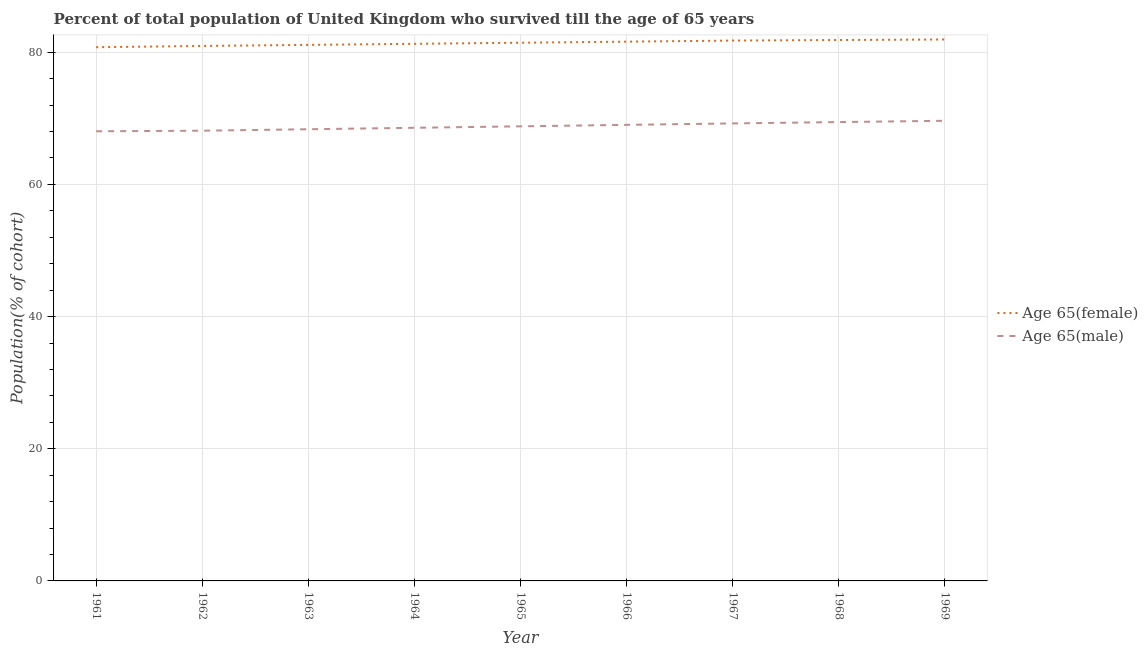How many different coloured lines are there?
Make the answer very short. 2. Does the line corresponding to percentage of male population who survived till age of 65 intersect with the line corresponding to percentage of female population who survived till age of 65?
Your answer should be compact. No. What is the percentage of male population who survived till age of 65 in 1964?
Your response must be concise. 68.57. Across all years, what is the maximum percentage of male population who survived till age of 65?
Provide a succinct answer. 69.63. Across all years, what is the minimum percentage of female population who survived till age of 65?
Offer a terse response. 80.76. In which year was the percentage of male population who survived till age of 65 maximum?
Offer a very short reply. 1969. What is the total percentage of female population who survived till age of 65 in the graph?
Ensure brevity in your answer.  732.68. What is the difference between the percentage of male population who survived till age of 65 in 1965 and that in 1967?
Your answer should be compact. -0.44. What is the difference between the percentage of male population who survived till age of 65 in 1961 and the percentage of female population who survived till age of 65 in 1967?
Make the answer very short. -13.73. What is the average percentage of female population who survived till age of 65 per year?
Give a very brief answer. 81.41. In the year 1965, what is the difference between the percentage of male population who survived till age of 65 and percentage of female population who survived till age of 65?
Provide a succinct answer. -12.65. What is the ratio of the percentage of male population who survived till age of 65 in 1967 to that in 1969?
Make the answer very short. 0.99. Is the percentage of female population who survived till age of 65 in 1966 less than that in 1967?
Give a very brief answer. Yes. What is the difference between the highest and the second highest percentage of male population who survived till age of 65?
Your answer should be very brief. 0.2. What is the difference between the highest and the lowest percentage of male population who survived till age of 65?
Provide a short and direct response. 1.59. In how many years, is the percentage of female population who survived till age of 65 greater than the average percentage of female population who survived till age of 65 taken over all years?
Give a very brief answer. 5. Is the sum of the percentage of male population who survived till age of 65 in 1961 and 1967 greater than the maximum percentage of female population who survived till age of 65 across all years?
Provide a short and direct response. Yes. Does the percentage of female population who survived till age of 65 monotonically increase over the years?
Offer a terse response. Yes. Is the percentage of male population who survived till age of 65 strictly greater than the percentage of female population who survived till age of 65 over the years?
Keep it short and to the point. No. Is the percentage of male population who survived till age of 65 strictly less than the percentage of female population who survived till age of 65 over the years?
Offer a terse response. Yes. What is the difference between two consecutive major ticks on the Y-axis?
Give a very brief answer. 20. Where does the legend appear in the graph?
Provide a succinct answer. Center right. How are the legend labels stacked?
Provide a short and direct response. Vertical. What is the title of the graph?
Provide a short and direct response. Percent of total population of United Kingdom who survived till the age of 65 years. Does "Urban agglomerations" appear as one of the legend labels in the graph?
Your answer should be compact. No. What is the label or title of the Y-axis?
Make the answer very short. Population(% of cohort). What is the Population(% of cohort) of Age 65(female) in 1961?
Provide a succinct answer. 80.76. What is the Population(% of cohort) of Age 65(male) in 1961?
Your answer should be very brief. 68.04. What is the Population(% of cohort) in Age 65(female) in 1962?
Offer a very short reply. 80.95. What is the Population(% of cohort) in Age 65(male) in 1962?
Your response must be concise. 68.13. What is the Population(% of cohort) in Age 65(female) in 1963?
Your response must be concise. 81.11. What is the Population(% of cohort) of Age 65(male) in 1963?
Make the answer very short. 68.35. What is the Population(% of cohort) of Age 65(female) in 1964?
Your response must be concise. 81.28. What is the Population(% of cohort) in Age 65(male) in 1964?
Keep it short and to the point. 68.57. What is the Population(% of cohort) of Age 65(female) in 1965?
Ensure brevity in your answer.  81.44. What is the Population(% of cohort) of Age 65(male) in 1965?
Your answer should be compact. 68.79. What is the Population(% of cohort) in Age 65(female) in 1966?
Provide a short and direct response. 81.6. What is the Population(% of cohort) of Age 65(male) in 1966?
Your response must be concise. 69.01. What is the Population(% of cohort) in Age 65(female) in 1967?
Give a very brief answer. 81.76. What is the Population(% of cohort) in Age 65(male) in 1967?
Make the answer very short. 69.23. What is the Population(% of cohort) of Age 65(female) in 1968?
Your response must be concise. 81.85. What is the Population(% of cohort) of Age 65(male) in 1968?
Offer a very short reply. 69.43. What is the Population(% of cohort) in Age 65(female) in 1969?
Provide a short and direct response. 81.93. What is the Population(% of cohort) in Age 65(male) in 1969?
Give a very brief answer. 69.63. Across all years, what is the maximum Population(% of cohort) in Age 65(female)?
Offer a terse response. 81.93. Across all years, what is the maximum Population(% of cohort) of Age 65(male)?
Ensure brevity in your answer.  69.63. Across all years, what is the minimum Population(% of cohort) of Age 65(female)?
Give a very brief answer. 80.76. Across all years, what is the minimum Population(% of cohort) in Age 65(male)?
Your answer should be very brief. 68.04. What is the total Population(% of cohort) in Age 65(female) in the graph?
Your answer should be very brief. 732.68. What is the total Population(% of cohort) in Age 65(male) in the graph?
Your answer should be compact. 619.17. What is the difference between the Population(% of cohort) in Age 65(female) in 1961 and that in 1962?
Your response must be concise. -0.19. What is the difference between the Population(% of cohort) of Age 65(male) in 1961 and that in 1962?
Offer a very short reply. -0.09. What is the difference between the Population(% of cohort) of Age 65(female) in 1961 and that in 1963?
Your response must be concise. -0.35. What is the difference between the Population(% of cohort) of Age 65(male) in 1961 and that in 1963?
Provide a short and direct response. -0.31. What is the difference between the Population(% of cohort) of Age 65(female) in 1961 and that in 1964?
Offer a terse response. -0.51. What is the difference between the Population(% of cohort) of Age 65(male) in 1961 and that in 1964?
Provide a succinct answer. -0.53. What is the difference between the Population(% of cohort) of Age 65(female) in 1961 and that in 1965?
Offer a very short reply. -0.68. What is the difference between the Population(% of cohort) in Age 65(male) in 1961 and that in 1965?
Provide a short and direct response. -0.75. What is the difference between the Population(% of cohort) of Age 65(female) in 1961 and that in 1966?
Provide a succinct answer. -0.84. What is the difference between the Population(% of cohort) of Age 65(male) in 1961 and that in 1966?
Your answer should be compact. -0.97. What is the difference between the Population(% of cohort) in Age 65(female) in 1961 and that in 1967?
Your answer should be compact. -1. What is the difference between the Population(% of cohort) in Age 65(male) in 1961 and that in 1967?
Offer a very short reply. -1.19. What is the difference between the Population(% of cohort) in Age 65(female) in 1961 and that in 1968?
Your response must be concise. -1.09. What is the difference between the Population(% of cohort) of Age 65(male) in 1961 and that in 1968?
Give a very brief answer. -1.39. What is the difference between the Population(% of cohort) in Age 65(female) in 1961 and that in 1969?
Make the answer very short. -1.17. What is the difference between the Population(% of cohort) of Age 65(male) in 1961 and that in 1969?
Your answer should be very brief. -1.59. What is the difference between the Population(% of cohort) in Age 65(female) in 1962 and that in 1963?
Offer a terse response. -0.16. What is the difference between the Population(% of cohort) in Age 65(male) in 1962 and that in 1963?
Ensure brevity in your answer.  -0.22. What is the difference between the Population(% of cohort) of Age 65(female) in 1962 and that in 1964?
Ensure brevity in your answer.  -0.33. What is the difference between the Population(% of cohort) of Age 65(male) in 1962 and that in 1964?
Keep it short and to the point. -0.44. What is the difference between the Population(% of cohort) of Age 65(female) in 1962 and that in 1965?
Your response must be concise. -0.49. What is the difference between the Population(% of cohort) of Age 65(male) in 1962 and that in 1965?
Keep it short and to the point. -0.66. What is the difference between the Population(% of cohort) of Age 65(female) in 1962 and that in 1966?
Provide a succinct answer. -0.65. What is the difference between the Population(% of cohort) in Age 65(male) in 1962 and that in 1966?
Give a very brief answer. -0.88. What is the difference between the Population(% of cohort) in Age 65(female) in 1962 and that in 1967?
Provide a short and direct response. -0.81. What is the difference between the Population(% of cohort) in Age 65(male) in 1962 and that in 1967?
Your answer should be very brief. -1.1. What is the difference between the Population(% of cohort) in Age 65(female) in 1962 and that in 1968?
Ensure brevity in your answer.  -0.9. What is the difference between the Population(% of cohort) in Age 65(male) in 1962 and that in 1968?
Give a very brief answer. -1.3. What is the difference between the Population(% of cohort) of Age 65(female) in 1962 and that in 1969?
Make the answer very short. -0.98. What is the difference between the Population(% of cohort) in Age 65(male) in 1962 and that in 1969?
Provide a short and direct response. -1.5. What is the difference between the Population(% of cohort) in Age 65(female) in 1963 and that in 1964?
Your answer should be very brief. -0.16. What is the difference between the Population(% of cohort) of Age 65(male) in 1963 and that in 1964?
Offer a terse response. -0.22. What is the difference between the Population(% of cohort) in Age 65(female) in 1963 and that in 1965?
Offer a terse response. -0.33. What is the difference between the Population(% of cohort) of Age 65(male) in 1963 and that in 1965?
Give a very brief answer. -0.44. What is the difference between the Population(% of cohort) in Age 65(female) in 1963 and that in 1966?
Your answer should be compact. -0.49. What is the difference between the Population(% of cohort) of Age 65(male) in 1963 and that in 1966?
Your answer should be compact. -0.66. What is the difference between the Population(% of cohort) in Age 65(female) in 1963 and that in 1967?
Provide a short and direct response. -0.65. What is the difference between the Population(% of cohort) in Age 65(male) in 1963 and that in 1967?
Your response must be concise. -0.88. What is the difference between the Population(% of cohort) in Age 65(female) in 1963 and that in 1968?
Make the answer very short. -0.74. What is the difference between the Population(% of cohort) of Age 65(male) in 1963 and that in 1968?
Your answer should be compact. -1.08. What is the difference between the Population(% of cohort) of Age 65(female) in 1963 and that in 1969?
Your answer should be very brief. -0.82. What is the difference between the Population(% of cohort) in Age 65(male) in 1963 and that in 1969?
Keep it short and to the point. -1.28. What is the difference between the Population(% of cohort) in Age 65(female) in 1964 and that in 1965?
Give a very brief answer. -0.16. What is the difference between the Population(% of cohort) of Age 65(male) in 1964 and that in 1965?
Ensure brevity in your answer.  -0.22. What is the difference between the Population(% of cohort) of Age 65(female) in 1964 and that in 1966?
Ensure brevity in your answer.  -0.33. What is the difference between the Population(% of cohort) of Age 65(male) in 1964 and that in 1966?
Offer a terse response. -0.44. What is the difference between the Population(% of cohort) of Age 65(female) in 1964 and that in 1967?
Give a very brief answer. -0.49. What is the difference between the Population(% of cohort) of Age 65(male) in 1964 and that in 1967?
Make the answer very short. -0.66. What is the difference between the Population(% of cohort) in Age 65(female) in 1964 and that in 1968?
Your response must be concise. -0.57. What is the difference between the Population(% of cohort) of Age 65(male) in 1964 and that in 1968?
Your response must be concise. -0.86. What is the difference between the Population(% of cohort) in Age 65(female) in 1964 and that in 1969?
Offer a very short reply. -0.66. What is the difference between the Population(% of cohort) in Age 65(male) in 1964 and that in 1969?
Your answer should be compact. -1.06. What is the difference between the Population(% of cohort) of Age 65(female) in 1965 and that in 1966?
Give a very brief answer. -0.16. What is the difference between the Population(% of cohort) in Age 65(male) in 1965 and that in 1966?
Your response must be concise. -0.22. What is the difference between the Population(% of cohort) in Age 65(female) in 1965 and that in 1967?
Your answer should be compact. -0.33. What is the difference between the Population(% of cohort) in Age 65(male) in 1965 and that in 1967?
Offer a terse response. -0.44. What is the difference between the Population(% of cohort) of Age 65(female) in 1965 and that in 1968?
Offer a very short reply. -0.41. What is the difference between the Population(% of cohort) of Age 65(male) in 1965 and that in 1968?
Provide a succinct answer. -0.64. What is the difference between the Population(% of cohort) in Age 65(female) in 1965 and that in 1969?
Offer a very short reply. -0.49. What is the difference between the Population(% of cohort) of Age 65(male) in 1965 and that in 1969?
Your response must be concise. -0.84. What is the difference between the Population(% of cohort) in Age 65(female) in 1966 and that in 1967?
Offer a terse response. -0.16. What is the difference between the Population(% of cohort) of Age 65(male) in 1966 and that in 1967?
Your answer should be compact. -0.22. What is the difference between the Population(% of cohort) of Age 65(female) in 1966 and that in 1968?
Keep it short and to the point. -0.25. What is the difference between the Population(% of cohort) of Age 65(male) in 1966 and that in 1968?
Give a very brief answer. -0.42. What is the difference between the Population(% of cohort) in Age 65(female) in 1966 and that in 1969?
Make the answer very short. -0.33. What is the difference between the Population(% of cohort) of Age 65(male) in 1966 and that in 1969?
Your answer should be compact. -0.62. What is the difference between the Population(% of cohort) in Age 65(female) in 1967 and that in 1968?
Provide a succinct answer. -0.08. What is the difference between the Population(% of cohort) in Age 65(male) in 1967 and that in 1968?
Your answer should be compact. -0.2. What is the difference between the Population(% of cohort) in Age 65(female) in 1967 and that in 1969?
Your response must be concise. -0.17. What is the difference between the Population(% of cohort) of Age 65(male) in 1967 and that in 1969?
Offer a very short reply. -0.4. What is the difference between the Population(% of cohort) in Age 65(female) in 1968 and that in 1969?
Keep it short and to the point. -0.08. What is the difference between the Population(% of cohort) in Age 65(male) in 1968 and that in 1969?
Give a very brief answer. -0.2. What is the difference between the Population(% of cohort) of Age 65(female) in 1961 and the Population(% of cohort) of Age 65(male) in 1962?
Provide a short and direct response. 12.63. What is the difference between the Population(% of cohort) of Age 65(female) in 1961 and the Population(% of cohort) of Age 65(male) in 1963?
Offer a very short reply. 12.41. What is the difference between the Population(% of cohort) in Age 65(female) in 1961 and the Population(% of cohort) in Age 65(male) in 1964?
Offer a very short reply. 12.19. What is the difference between the Population(% of cohort) in Age 65(female) in 1961 and the Population(% of cohort) in Age 65(male) in 1965?
Give a very brief answer. 11.97. What is the difference between the Population(% of cohort) in Age 65(female) in 1961 and the Population(% of cohort) in Age 65(male) in 1966?
Provide a short and direct response. 11.75. What is the difference between the Population(% of cohort) of Age 65(female) in 1961 and the Population(% of cohort) of Age 65(male) in 1967?
Offer a terse response. 11.53. What is the difference between the Population(% of cohort) in Age 65(female) in 1961 and the Population(% of cohort) in Age 65(male) in 1968?
Provide a short and direct response. 11.33. What is the difference between the Population(% of cohort) of Age 65(female) in 1961 and the Population(% of cohort) of Age 65(male) in 1969?
Keep it short and to the point. 11.13. What is the difference between the Population(% of cohort) of Age 65(female) in 1962 and the Population(% of cohort) of Age 65(male) in 1963?
Make the answer very short. 12.6. What is the difference between the Population(% of cohort) in Age 65(female) in 1962 and the Population(% of cohort) in Age 65(male) in 1964?
Provide a succinct answer. 12.38. What is the difference between the Population(% of cohort) in Age 65(female) in 1962 and the Population(% of cohort) in Age 65(male) in 1965?
Keep it short and to the point. 12.16. What is the difference between the Population(% of cohort) in Age 65(female) in 1962 and the Population(% of cohort) in Age 65(male) in 1966?
Provide a succinct answer. 11.94. What is the difference between the Population(% of cohort) in Age 65(female) in 1962 and the Population(% of cohort) in Age 65(male) in 1967?
Your answer should be compact. 11.72. What is the difference between the Population(% of cohort) of Age 65(female) in 1962 and the Population(% of cohort) of Age 65(male) in 1968?
Make the answer very short. 11.52. What is the difference between the Population(% of cohort) of Age 65(female) in 1962 and the Population(% of cohort) of Age 65(male) in 1969?
Offer a terse response. 11.32. What is the difference between the Population(% of cohort) of Age 65(female) in 1963 and the Population(% of cohort) of Age 65(male) in 1964?
Keep it short and to the point. 12.54. What is the difference between the Population(% of cohort) of Age 65(female) in 1963 and the Population(% of cohort) of Age 65(male) in 1965?
Your answer should be compact. 12.32. What is the difference between the Population(% of cohort) in Age 65(female) in 1963 and the Population(% of cohort) in Age 65(male) in 1966?
Offer a very short reply. 12.1. What is the difference between the Population(% of cohort) in Age 65(female) in 1963 and the Population(% of cohort) in Age 65(male) in 1967?
Offer a terse response. 11.88. What is the difference between the Population(% of cohort) of Age 65(female) in 1963 and the Population(% of cohort) of Age 65(male) in 1968?
Keep it short and to the point. 11.68. What is the difference between the Population(% of cohort) in Age 65(female) in 1963 and the Population(% of cohort) in Age 65(male) in 1969?
Provide a short and direct response. 11.48. What is the difference between the Population(% of cohort) in Age 65(female) in 1964 and the Population(% of cohort) in Age 65(male) in 1965?
Offer a very short reply. 12.49. What is the difference between the Population(% of cohort) in Age 65(female) in 1964 and the Population(% of cohort) in Age 65(male) in 1966?
Offer a very short reply. 12.26. What is the difference between the Population(% of cohort) in Age 65(female) in 1964 and the Population(% of cohort) in Age 65(male) in 1967?
Your response must be concise. 12.04. What is the difference between the Population(% of cohort) of Age 65(female) in 1964 and the Population(% of cohort) of Age 65(male) in 1968?
Offer a terse response. 11.84. What is the difference between the Population(% of cohort) in Age 65(female) in 1964 and the Population(% of cohort) in Age 65(male) in 1969?
Keep it short and to the point. 11.65. What is the difference between the Population(% of cohort) in Age 65(female) in 1965 and the Population(% of cohort) in Age 65(male) in 1966?
Ensure brevity in your answer.  12.43. What is the difference between the Population(% of cohort) of Age 65(female) in 1965 and the Population(% of cohort) of Age 65(male) in 1967?
Your response must be concise. 12.21. What is the difference between the Population(% of cohort) of Age 65(female) in 1965 and the Population(% of cohort) of Age 65(male) in 1968?
Provide a short and direct response. 12.01. What is the difference between the Population(% of cohort) of Age 65(female) in 1965 and the Population(% of cohort) of Age 65(male) in 1969?
Keep it short and to the point. 11.81. What is the difference between the Population(% of cohort) in Age 65(female) in 1966 and the Population(% of cohort) in Age 65(male) in 1967?
Make the answer very short. 12.37. What is the difference between the Population(% of cohort) in Age 65(female) in 1966 and the Population(% of cohort) in Age 65(male) in 1968?
Provide a succinct answer. 12.17. What is the difference between the Population(% of cohort) in Age 65(female) in 1966 and the Population(% of cohort) in Age 65(male) in 1969?
Ensure brevity in your answer.  11.97. What is the difference between the Population(% of cohort) of Age 65(female) in 1967 and the Population(% of cohort) of Age 65(male) in 1968?
Keep it short and to the point. 12.33. What is the difference between the Population(% of cohort) of Age 65(female) in 1967 and the Population(% of cohort) of Age 65(male) in 1969?
Your response must be concise. 12.13. What is the difference between the Population(% of cohort) of Age 65(female) in 1968 and the Population(% of cohort) of Age 65(male) in 1969?
Ensure brevity in your answer.  12.22. What is the average Population(% of cohort) in Age 65(female) per year?
Offer a terse response. 81.41. What is the average Population(% of cohort) of Age 65(male) per year?
Your answer should be compact. 68.8. In the year 1961, what is the difference between the Population(% of cohort) of Age 65(female) and Population(% of cohort) of Age 65(male)?
Provide a succinct answer. 12.72. In the year 1962, what is the difference between the Population(% of cohort) of Age 65(female) and Population(% of cohort) of Age 65(male)?
Provide a succinct answer. 12.82. In the year 1963, what is the difference between the Population(% of cohort) of Age 65(female) and Population(% of cohort) of Age 65(male)?
Your response must be concise. 12.76. In the year 1964, what is the difference between the Population(% of cohort) of Age 65(female) and Population(% of cohort) of Age 65(male)?
Give a very brief answer. 12.71. In the year 1965, what is the difference between the Population(% of cohort) in Age 65(female) and Population(% of cohort) in Age 65(male)?
Your answer should be compact. 12.65. In the year 1966, what is the difference between the Population(% of cohort) of Age 65(female) and Population(% of cohort) of Age 65(male)?
Your answer should be very brief. 12.59. In the year 1967, what is the difference between the Population(% of cohort) in Age 65(female) and Population(% of cohort) in Age 65(male)?
Provide a short and direct response. 12.53. In the year 1968, what is the difference between the Population(% of cohort) of Age 65(female) and Population(% of cohort) of Age 65(male)?
Offer a terse response. 12.42. In the year 1969, what is the difference between the Population(% of cohort) of Age 65(female) and Population(% of cohort) of Age 65(male)?
Offer a very short reply. 12.3. What is the ratio of the Population(% of cohort) in Age 65(female) in 1961 to that in 1963?
Make the answer very short. 1. What is the ratio of the Population(% of cohort) in Age 65(male) in 1961 to that in 1963?
Your answer should be very brief. 1. What is the ratio of the Population(% of cohort) in Age 65(female) in 1961 to that in 1964?
Keep it short and to the point. 0.99. What is the ratio of the Population(% of cohort) in Age 65(male) in 1961 to that in 1964?
Your answer should be compact. 0.99. What is the ratio of the Population(% of cohort) of Age 65(female) in 1961 to that in 1965?
Keep it short and to the point. 0.99. What is the ratio of the Population(% of cohort) in Age 65(male) in 1961 to that in 1965?
Provide a short and direct response. 0.99. What is the ratio of the Population(% of cohort) of Age 65(male) in 1961 to that in 1966?
Your response must be concise. 0.99. What is the ratio of the Population(% of cohort) in Age 65(female) in 1961 to that in 1967?
Give a very brief answer. 0.99. What is the ratio of the Population(% of cohort) of Age 65(male) in 1961 to that in 1967?
Provide a short and direct response. 0.98. What is the ratio of the Population(% of cohort) in Age 65(female) in 1961 to that in 1968?
Provide a short and direct response. 0.99. What is the ratio of the Population(% of cohort) of Age 65(female) in 1961 to that in 1969?
Your answer should be compact. 0.99. What is the ratio of the Population(% of cohort) in Age 65(male) in 1961 to that in 1969?
Ensure brevity in your answer.  0.98. What is the ratio of the Population(% of cohort) in Age 65(male) in 1962 to that in 1964?
Keep it short and to the point. 0.99. What is the ratio of the Population(% of cohort) in Age 65(female) in 1962 to that in 1965?
Your answer should be compact. 0.99. What is the ratio of the Population(% of cohort) of Age 65(male) in 1962 to that in 1965?
Ensure brevity in your answer.  0.99. What is the ratio of the Population(% of cohort) of Age 65(male) in 1962 to that in 1966?
Keep it short and to the point. 0.99. What is the ratio of the Population(% of cohort) of Age 65(female) in 1962 to that in 1967?
Your response must be concise. 0.99. What is the ratio of the Population(% of cohort) of Age 65(male) in 1962 to that in 1967?
Offer a terse response. 0.98. What is the ratio of the Population(% of cohort) of Age 65(female) in 1962 to that in 1968?
Make the answer very short. 0.99. What is the ratio of the Population(% of cohort) of Age 65(male) in 1962 to that in 1968?
Make the answer very short. 0.98. What is the ratio of the Population(% of cohort) of Age 65(male) in 1962 to that in 1969?
Make the answer very short. 0.98. What is the ratio of the Population(% of cohort) of Age 65(female) in 1963 to that in 1964?
Your answer should be very brief. 1. What is the ratio of the Population(% of cohort) in Age 65(female) in 1963 to that in 1965?
Keep it short and to the point. 1. What is the ratio of the Population(% of cohort) in Age 65(male) in 1963 to that in 1965?
Your answer should be very brief. 0.99. What is the ratio of the Population(% of cohort) of Age 65(male) in 1963 to that in 1966?
Keep it short and to the point. 0.99. What is the ratio of the Population(% of cohort) of Age 65(male) in 1963 to that in 1967?
Provide a short and direct response. 0.99. What is the ratio of the Population(% of cohort) of Age 65(male) in 1963 to that in 1968?
Offer a terse response. 0.98. What is the ratio of the Population(% of cohort) of Age 65(male) in 1963 to that in 1969?
Give a very brief answer. 0.98. What is the ratio of the Population(% of cohort) of Age 65(female) in 1964 to that in 1965?
Offer a very short reply. 1. What is the ratio of the Population(% of cohort) in Age 65(female) in 1964 to that in 1966?
Keep it short and to the point. 1. What is the ratio of the Population(% of cohort) in Age 65(male) in 1964 to that in 1966?
Provide a succinct answer. 0.99. What is the ratio of the Population(% of cohort) of Age 65(male) in 1964 to that in 1967?
Offer a very short reply. 0.99. What is the ratio of the Population(% of cohort) of Age 65(female) in 1964 to that in 1968?
Provide a short and direct response. 0.99. What is the ratio of the Population(% of cohort) in Age 65(male) in 1964 to that in 1968?
Offer a terse response. 0.99. What is the ratio of the Population(% of cohort) in Age 65(female) in 1964 to that in 1969?
Keep it short and to the point. 0.99. What is the ratio of the Population(% of cohort) in Age 65(female) in 1965 to that in 1966?
Make the answer very short. 1. What is the ratio of the Population(% of cohort) of Age 65(female) in 1965 to that in 1967?
Offer a terse response. 1. What is the ratio of the Population(% of cohort) in Age 65(male) in 1965 to that in 1968?
Provide a short and direct response. 0.99. What is the ratio of the Population(% of cohort) of Age 65(female) in 1965 to that in 1969?
Provide a succinct answer. 0.99. What is the ratio of the Population(% of cohort) of Age 65(male) in 1965 to that in 1969?
Give a very brief answer. 0.99. What is the ratio of the Population(% of cohort) of Age 65(female) in 1966 to that in 1968?
Offer a terse response. 1. What is the ratio of the Population(% of cohort) of Age 65(male) in 1966 to that in 1969?
Give a very brief answer. 0.99. What is the ratio of the Population(% of cohort) in Age 65(female) in 1967 to that in 1969?
Give a very brief answer. 1. What is the ratio of the Population(% of cohort) of Age 65(male) in 1967 to that in 1969?
Your answer should be compact. 0.99. What is the ratio of the Population(% of cohort) in Age 65(female) in 1968 to that in 1969?
Offer a very short reply. 1. What is the ratio of the Population(% of cohort) in Age 65(male) in 1968 to that in 1969?
Ensure brevity in your answer.  1. What is the difference between the highest and the second highest Population(% of cohort) in Age 65(female)?
Provide a short and direct response. 0.08. What is the difference between the highest and the second highest Population(% of cohort) in Age 65(male)?
Offer a terse response. 0.2. What is the difference between the highest and the lowest Population(% of cohort) of Age 65(female)?
Your response must be concise. 1.17. What is the difference between the highest and the lowest Population(% of cohort) in Age 65(male)?
Your answer should be compact. 1.59. 